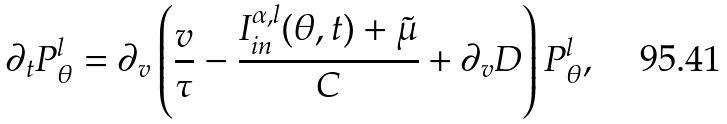Convert formula to latex. <formula><loc_0><loc_0><loc_500><loc_500>\partial _ { t } P ^ { l } _ { \theta } = \partial _ { v } \left ( \frac { v } { \tau } - \frac { I ^ { \alpha , l } _ { i n } ( \theta , t ) + \tilde { \mu } } { C } + \partial _ { v } D \right ) P ^ { l } _ { \theta } ,</formula> 